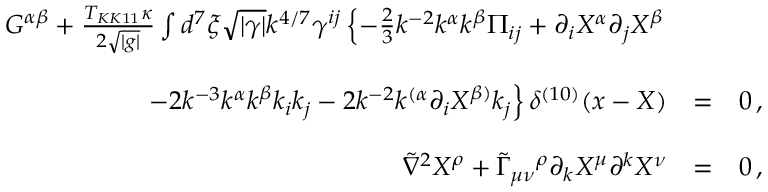<formula> <loc_0><loc_0><loc_500><loc_500>\begin{array} { r c l } { { G ^ { \alpha \beta } + { \frac { T _ { K K 1 1 } \kappa } { 2 \sqrt { | g | } } } \int d ^ { 7 } \xi \sqrt { | \gamma | } k ^ { 4 / 7 } \gamma ^ { i j } \left \{ - \frac { 2 } { 3 } k ^ { - 2 } k ^ { \alpha } k ^ { \beta } \Pi _ { i j } + \partial _ { i } X ^ { \alpha } \partial _ { j } X ^ { \beta } } } \\ { { - 2 k ^ { - 3 } k ^ { \alpha } k ^ { \beta } k _ { i } k _ { j } - 2 k ^ { - 2 } k ^ { ( \alpha } \partial _ { i } X ^ { \beta ) } k _ { j } \right \} \delta ^ { ( 1 0 ) } ( x - X ) } } & { = } & { 0 \, , } \\ { { \tilde { \nabla } ^ { 2 } X ^ { \rho } + \tilde { \Gamma } _ { \mu \nu ^ { \rho } \partial _ { k } X ^ { \mu } \partial ^ { k } X ^ { \nu } } } & { = } & { 0 \, , } \end{array}</formula> 